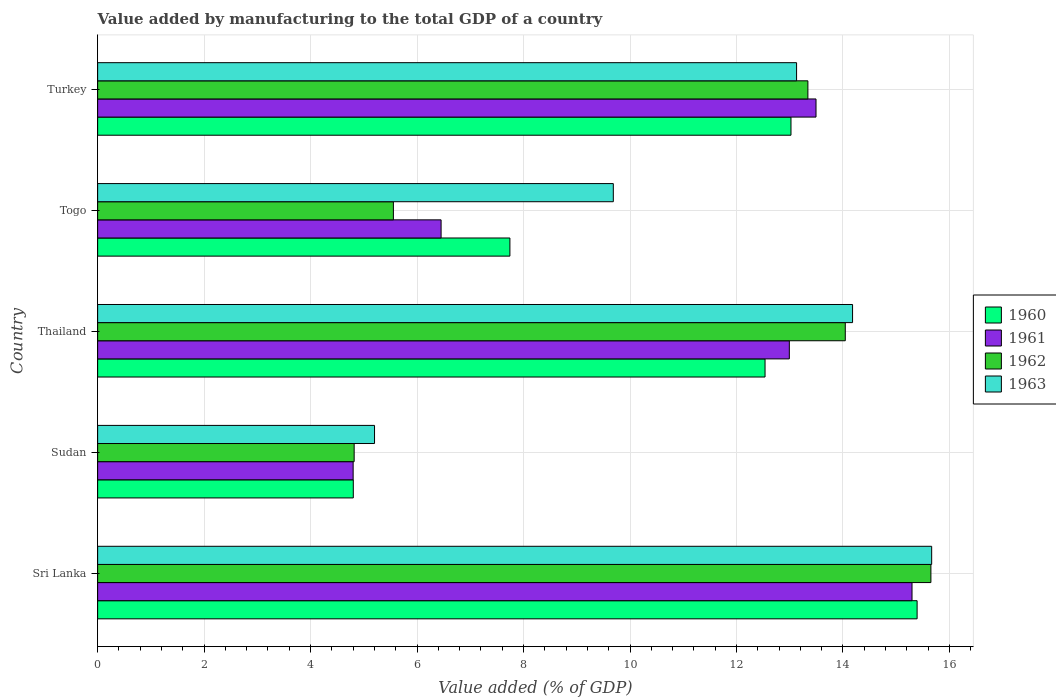How many groups of bars are there?
Ensure brevity in your answer.  5. Are the number of bars per tick equal to the number of legend labels?
Your answer should be compact. Yes. Are the number of bars on each tick of the Y-axis equal?
Your response must be concise. Yes. How many bars are there on the 3rd tick from the top?
Provide a succinct answer. 4. How many bars are there on the 3rd tick from the bottom?
Offer a terse response. 4. What is the label of the 2nd group of bars from the top?
Your answer should be compact. Togo. In how many cases, is the number of bars for a given country not equal to the number of legend labels?
Offer a terse response. 0. What is the value added by manufacturing to the total GDP in 1962 in Turkey?
Give a very brief answer. 13.34. Across all countries, what is the maximum value added by manufacturing to the total GDP in 1963?
Your answer should be very brief. 15.67. Across all countries, what is the minimum value added by manufacturing to the total GDP in 1962?
Your answer should be compact. 4.82. In which country was the value added by manufacturing to the total GDP in 1960 maximum?
Provide a short and direct response. Sri Lanka. In which country was the value added by manufacturing to the total GDP in 1960 minimum?
Keep it short and to the point. Sudan. What is the total value added by manufacturing to the total GDP in 1963 in the graph?
Your answer should be compact. 57.86. What is the difference between the value added by manufacturing to the total GDP in 1963 in Thailand and that in Togo?
Make the answer very short. 4.49. What is the difference between the value added by manufacturing to the total GDP in 1961 in Togo and the value added by manufacturing to the total GDP in 1963 in Thailand?
Your answer should be compact. -7.73. What is the average value added by manufacturing to the total GDP in 1961 per country?
Your answer should be compact. 10.61. What is the difference between the value added by manufacturing to the total GDP in 1963 and value added by manufacturing to the total GDP in 1961 in Togo?
Offer a terse response. 3.23. What is the ratio of the value added by manufacturing to the total GDP in 1961 in Sudan to that in Togo?
Make the answer very short. 0.74. Is the value added by manufacturing to the total GDP in 1960 in Thailand less than that in Turkey?
Your answer should be compact. Yes. Is the difference between the value added by manufacturing to the total GDP in 1963 in Sudan and Thailand greater than the difference between the value added by manufacturing to the total GDP in 1961 in Sudan and Thailand?
Your answer should be compact. No. What is the difference between the highest and the second highest value added by manufacturing to the total GDP in 1962?
Offer a very short reply. 1.61. What is the difference between the highest and the lowest value added by manufacturing to the total GDP in 1960?
Ensure brevity in your answer.  10.59. Is the sum of the value added by manufacturing to the total GDP in 1963 in Thailand and Togo greater than the maximum value added by manufacturing to the total GDP in 1960 across all countries?
Provide a short and direct response. Yes. Is it the case that in every country, the sum of the value added by manufacturing to the total GDP in 1962 and value added by manufacturing to the total GDP in 1963 is greater than the sum of value added by manufacturing to the total GDP in 1961 and value added by manufacturing to the total GDP in 1960?
Your answer should be compact. No. What does the 1st bar from the bottom in Togo represents?
Make the answer very short. 1960. How many bars are there?
Keep it short and to the point. 20. Are all the bars in the graph horizontal?
Your response must be concise. Yes. How many countries are there in the graph?
Offer a terse response. 5. What is the difference between two consecutive major ticks on the X-axis?
Keep it short and to the point. 2. Are the values on the major ticks of X-axis written in scientific E-notation?
Provide a succinct answer. No. Does the graph contain grids?
Ensure brevity in your answer.  Yes. Where does the legend appear in the graph?
Your answer should be very brief. Center right. How many legend labels are there?
Keep it short and to the point. 4. What is the title of the graph?
Provide a succinct answer. Value added by manufacturing to the total GDP of a country. What is the label or title of the X-axis?
Offer a very short reply. Value added (% of GDP). What is the Value added (% of GDP) of 1960 in Sri Lanka?
Keep it short and to the point. 15.39. What is the Value added (% of GDP) of 1961 in Sri Lanka?
Your answer should be compact. 15.3. What is the Value added (% of GDP) of 1962 in Sri Lanka?
Your answer should be compact. 15.65. What is the Value added (% of GDP) in 1963 in Sri Lanka?
Provide a short and direct response. 15.67. What is the Value added (% of GDP) in 1960 in Sudan?
Give a very brief answer. 4.8. What is the Value added (% of GDP) in 1961 in Sudan?
Offer a very short reply. 4.8. What is the Value added (% of GDP) of 1962 in Sudan?
Offer a terse response. 4.82. What is the Value added (% of GDP) in 1963 in Sudan?
Your response must be concise. 5.2. What is the Value added (% of GDP) in 1960 in Thailand?
Keep it short and to the point. 12.54. What is the Value added (% of GDP) in 1961 in Thailand?
Your answer should be very brief. 12.99. What is the Value added (% of GDP) in 1962 in Thailand?
Ensure brevity in your answer.  14.04. What is the Value added (% of GDP) in 1963 in Thailand?
Provide a succinct answer. 14.18. What is the Value added (% of GDP) of 1960 in Togo?
Your response must be concise. 7.74. What is the Value added (% of GDP) of 1961 in Togo?
Ensure brevity in your answer.  6.45. What is the Value added (% of GDP) of 1962 in Togo?
Give a very brief answer. 5.56. What is the Value added (% of GDP) in 1963 in Togo?
Provide a short and direct response. 9.69. What is the Value added (% of GDP) in 1960 in Turkey?
Keep it short and to the point. 13.02. What is the Value added (% of GDP) in 1961 in Turkey?
Make the answer very short. 13.49. What is the Value added (% of GDP) in 1962 in Turkey?
Ensure brevity in your answer.  13.34. What is the Value added (% of GDP) in 1963 in Turkey?
Provide a short and direct response. 13.13. Across all countries, what is the maximum Value added (% of GDP) in 1960?
Your answer should be compact. 15.39. Across all countries, what is the maximum Value added (% of GDP) in 1961?
Give a very brief answer. 15.3. Across all countries, what is the maximum Value added (% of GDP) of 1962?
Your answer should be very brief. 15.65. Across all countries, what is the maximum Value added (% of GDP) of 1963?
Offer a very short reply. 15.67. Across all countries, what is the minimum Value added (% of GDP) in 1960?
Your answer should be very brief. 4.8. Across all countries, what is the minimum Value added (% of GDP) in 1961?
Make the answer very short. 4.8. Across all countries, what is the minimum Value added (% of GDP) of 1962?
Make the answer very short. 4.82. Across all countries, what is the minimum Value added (% of GDP) in 1963?
Ensure brevity in your answer.  5.2. What is the total Value added (% of GDP) in 1960 in the graph?
Make the answer very short. 53.5. What is the total Value added (% of GDP) of 1961 in the graph?
Ensure brevity in your answer.  53.04. What is the total Value added (% of GDP) of 1962 in the graph?
Provide a short and direct response. 53.41. What is the total Value added (% of GDP) in 1963 in the graph?
Provide a succinct answer. 57.86. What is the difference between the Value added (% of GDP) in 1960 in Sri Lanka and that in Sudan?
Offer a very short reply. 10.59. What is the difference between the Value added (% of GDP) of 1961 in Sri Lanka and that in Sudan?
Provide a succinct answer. 10.5. What is the difference between the Value added (% of GDP) of 1962 in Sri Lanka and that in Sudan?
Ensure brevity in your answer.  10.83. What is the difference between the Value added (% of GDP) of 1963 in Sri Lanka and that in Sudan?
Ensure brevity in your answer.  10.47. What is the difference between the Value added (% of GDP) in 1960 in Sri Lanka and that in Thailand?
Make the answer very short. 2.86. What is the difference between the Value added (% of GDP) of 1961 in Sri Lanka and that in Thailand?
Provide a succinct answer. 2.3. What is the difference between the Value added (% of GDP) in 1962 in Sri Lanka and that in Thailand?
Provide a short and direct response. 1.61. What is the difference between the Value added (% of GDP) of 1963 in Sri Lanka and that in Thailand?
Provide a succinct answer. 1.49. What is the difference between the Value added (% of GDP) of 1960 in Sri Lanka and that in Togo?
Provide a succinct answer. 7.65. What is the difference between the Value added (% of GDP) in 1961 in Sri Lanka and that in Togo?
Keep it short and to the point. 8.85. What is the difference between the Value added (% of GDP) of 1962 in Sri Lanka and that in Togo?
Offer a very short reply. 10.1. What is the difference between the Value added (% of GDP) in 1963 in Sri Lanka and that in Togo?
Offer a terse response. 5.98. What is the difference between the Value added (% of GDP) in 1960 in Sri Lanka and that in Turkey?
Your answer should be compact. 2.37. What is the difference between the Value added (% of GDP) in 1961 in Sri Lanka and that in Turkey?
Offer a very short reply. 1.8. What is the difference between the Value added (% of GDP) in 1962 in Sri Lanka and that in Turkey?
Keep it short and to the point. 2.31. What is the difference between the Value added (% of GDP) in 1963 in Sri Lanka and that in Turkey?
Provide a short and direct response. 2.54. What is the difference between the Value added (% of GDP) of 1960 in Sudan and that in Thailand?
Offer a very short reply. -7.73. What is the difference between the Value added (% of GDP) in 1961 in Sudan and that in Thailand?
Make the answer very short. -8.19. What is the difference between the Value added (% of GDP) of 1962 in Sudan and that in Thailand?
Your answer should be compact. -9.23. What is the difference between the Value added (% of GDP) of 1963 in Sudan and that in Thailand?
Your response must be concise. -8.98. What is the difference between the Value added (% of GDP) of 1960 in Sudan and that in Togo?
Keep it short and to the point. -2.94. What is the difference between the Value added (% of GDP) of 1961 in Sudan and that in Togo?
Your answer should be compact. -1.65. What is the difference between the Value added (% of GDP) in 1962 in Sudan and that in Togo?
Offer a terse response. -0.74. What is the difference between the Value added (% of GDP) in 1963 in Sudan and that in Togo?
Offer a terse response. -4.49. What is the difference between the Value added (% of GDP) in 1960 in Sudan and that in Turkey?
Provide a short and direct response. -8.22. What is the difference between the Value added (% of GDP) of 1961 in Sudan and that in Turkey?
Offer a very short reply. -8.69. What is the difference between the Value added (% of GDP) of 1962 in Sudan and that in Turkey?
Ensure brevity in your answer.  -8.52. What is the difference between the Value added (% of GDP) of 1963 in Sudan and that in Turkey?
Offer a very short reply. -7.93. What is the difference between the Value added (% of GDP) of 1960 in Thailand and that in Togo?
Provide a short and direct response. 4.79. What is the difference between the Value added (% of GDP) in 1961 in Thailand and that in Togo?
Provide a short and direct response. 6.54. What is the difference between the Value added (% of GDP) of 1962 in Thailand and that in Togo?
Your response must be concise. 8.49. What is the difference between the Value added (% of GDP) of 1963 in Thailand and that in Togo?
Offer a terse response. 4.49. What is the difference between the Value added (% of GDP) of 1960 in Thailand and that in Turkey?
Provide a short and direct response. -0.49. What is the difference between the Value added (% of GDP) of 1961 in Thailand and that in Turkey?
Make the answer very short. -0.5. What is the difference between the Value added (% of GDP) of 1962 in Thailand and that in Turkey?
Ensure brevity in your answer.  0.7. What is the difference between the Value added (% of GDP) in 1963 in Thailand and that in Turkey?
Keep it short and to the point. 1.05. What is the difference between the Value added (% of GDP) of 1960 in Togo and that in Turkey?
Your response must be concise. -5.28. What is the difference between the Value added (% of GDP) in 1961 in Togo and that in Turkey?
Your answer should be very brief. -7.04. What is the difference between the Value added (% of GDP) in 1962 in Togo and that in Turkey?
Make the answer very short. -7.79. What is the difference between the Value added (% of GDP) in 1963 in Togo and that in Turkey?
Your answer should be compact. -3.44. What is the difference between the Value added (% of GDP) in 1960 in Sri Lanka and the Value added (% of GDP) in 1961 in Sudan?
Provide a succinct answer. 10.59. What is the difference between the Value added (% of GDP) in 1960 in Sri Lanka and the Value added (% of GDP) in 1962 in Sudan?
Offer a terse response. 10.57. What is the difference between the Value added (% of GDP) in 1960 in Sri Lanka and the Value added (% of GDP) in 1963 in Sudan?
Provide a succinct answer. 10.19. What is the difference between the Value added (% of GDP) of 1961 in Sri Lanka and the Value added (% of GDP) of 1962 in Sudan?
Keep it short and to the point. 10.48. What is the difference between the Value added (% of GDP) of 1961 in Sri Lanka and the Value added (% of GDP) of 1963 in Sudan?
Your response must be concise. 10.1. What is the difference between the Value added (% of GDP) of 1962 in Sri Lanka and the Value added (% of GDP) of 1963 in Sudan?
Keep it short and to the point. 10.45. What is the difference between the Value added (% of GDP) of 1960 in Sri Lanka and the Value added (% of GDP) of 1961 in Thailand?
Offer a very short reply. 2.4. What is the difference between the Value added (% of GDP) in 1960 in Sri Lanka and the Value added (% of GDP) in 1962 in Thailand?
Provide a short and direct response. 1.35. What is the difference between the Value added (% of GDP) in 1960 in Sri Lanka and the Value added (% of GDP) in 1963 in Thailand?
Your answer should be compact. 1.21. What is the difference between the Value added (% of GDP) in 1961 in Sri Lanka and the Value added (% of GDP) in 1962 in Thailand?
Offer a terse response. 1.25. What is the difference between the Value added (% of GDP) in 1961 in Sri Lanka and the Value added (% of GDP) in 1963 in Thailand?
Give a very brief answer. 1.12. What is the difference between the Value added (% of GDP) in 1962 in Sri Lanka and the Value added (% of GDP) in 1963 in Thailand?
Your answer should be compact. 1.47. What is the difference between the Value added (% of GDP) in 1960 in Sri Lanka and the Value added (% of GDP) in 1961 in Togo?
Make the answer very short. 8.94. What is the difference between the Value added (% of GDP) in 1960 in Sri Lanka and the Value added (% of GDP) in 1962 in Togo?
Provide a short and direct response. 9.84. What is the difference between the Value added (% of GDP) of 1960 in Sri Lanka and the Value added (% of GDP) of 1963 in Togo?
Offer a terse response. 5.71. What is the difference between the Value added (% of GDP) of 1961 in Sri Lanka and the Value added (% of GDP) of 1962 in Togo?
Offer a very short reply. 9.74. What is the difference between the Value added (% of GDP) of 1961 in Sri Lanka and the Value added (% of GDP) of 1963 in Togo?
Ensure brevity in your answer.  5.61. What is the difference between the Value added (% of GDP) of 1962 in Sri Lanka and the Value added (% of GDP) of 1963 in Togo?
Make the answer very short. 5.97. What is the difference between the Value added (% of GDP) in 1960 in Sri Lanka and the Value added (% of GDP) in 1961 in Turkey?
Your response must be concise. 1.9. What is the difference between the Value added (% of GDP) in 1960 in Sri Lanka and the Value added (% of GDP) in 1962 in Turkey?
Provide a short and direct response. 2.05. What is the difference between the Value added (% of GDP) of 1960 in Sri Lanka and the Value added (% of GDP) of 1963 in Turkey?
Provide a short and direct response. 2.26. What is the difference between the Value added (% of GDP) in 1961 in Sri Lanka and the Value added (% of GDP) in 1962 in Turkey?
Keep it short and to the point. 1.96. What is the difference between the Value added (% of GDP) in 1961 in Sri Lanka and the Value added (% of GDP) in 1963 in Turkey?
Give a very brief answer. 2.17. What is the difference between the Value added (% of GDP) in 1962 in Sri Lanka and the Value added (% of GDP) in 1963 in Turkey?
Your answer should be very brief. 2.52. What is the difference between the Value added (% of GDP) in 1960 in Sudan and the Value added (% of GDP) in 1961 in Thailand?
Keep it short and to the point. -8.19. What is the difference between the Value added (% of GDP) of 1960 in Sudan and the Value added (% of GDP) of 1962 in Thailand?
Offer a terse response. -9.24. What is the difference between the Value added (% of GDP) of 1960 in Sudan and the Value added (% of GDP) of 1963 in Thailand?
Offer a terse response. -9.38. What is the difference between the Value added (% of GDP) in 1961 in Sudan and the Value added (% of GDP) in 1962 in Thailand?
Your answer should be very brief. -9.24. What is the difference between the Value added (% of GDP) in 1961 in Sudan and the Value added (% of GDP) in 1963 in Thailand?
Your response must be concise. -9.38. What is the difference between the Value added (% of GDP) in 1962 in Sudan and the Value added (% of GDP) in 1963 in Thailand?
Keep it short and to the point. -9.36. What is the difference between the Value added (% of GDP) in 1960 in Sudan and the Value added (% of GDP) in 1961 in Togo?
Offer a terse response. -1.65. What is the difference between the Value added (% of GDP) in 1960 in Sudan and the Value added (% of GDP) in 1962 in Togo?
Ensure brevity in your answer.  -0.75. What is the difference between the Value added (% of GDP) in 1960 in Sudan and the Value added (% of GDP) in 1963 in Togo?
Give a very brief answer. -4.88. What is the difference between the Value added (% of GDP) in 1961 in Sudan and the Value added (% of GDP) in 1962 in Togo?
Provide a short and direct response. -0.76. What is the difference between the Value added (% of GDP) in 1961 in Sudan and the Value added (% of GDP) in 1963 in Togo?
Make the answer very short. -4.89. What is the difference between the Value added (% of GDP) in 1962 in Sudan and the Value added (% of GDP) in 1963 in Togo?
Offer a terse response. -4.87. What is the difference between the Value added (% of GDP) of 1960 in Sudan and the Value added (% of GDP) of 1961 in Turkey?
Offer a very short reply. -8.69. What is the difference between the Value added (% of GDP) in 1960 in Sudan and the Value added (% of GDP) in 1962 in Turkey?
Offer a very short reply. -8.54. What is the difference between the Value added (% of GDP) of 1960 in Sudan and the Value added (% of GDP) of 1963 in Turkey?
Offer a terse response. -8.33. What is the difference between the Value added (% of GDP) of 1961 in Sudan and the Value added (% of GDP) of 1962 in Turkey?
Provide a short and direct response. -8.54. What is the difference between the Value added (% of GDP) in 1961 in Sudan and the Value added (% of GDP) in 1963 in Turkey?
Offer a terse response. -8.33. What is the difference between the Value added (% of GDP) of 1962 in Sudan and the Value added (% of GDP) of 1963 in Turkey?
Provide a succinct answer. -8.31. What is the difference between the Value added (% of GDP) of 1960 in Thailand and the Value added (% of GDP) of 1961 in Togo?
Provide a short and direct response. 6.09. What is the difference between the Value added (% of GDP) of 1960 in Thailand and the Value added (% of GDP) of 1962 in Togo?
Keep it short and to the point. 6.98. What is the difference between the Value added (% of GDP) of 1960 in Thailand and the Value added (% of GDP) of 1963 in Togo?
Your response must be concise. 2.85. What is the difference between the Value added (% of GDP) in 1961 in Thailand and the Value added (% of GDP) in 1962 in Togo?
Offer a very short reply. 7.44. What is the difference between the Value added (% of GDP) in 1961 in Thailand and the Value added (% of GDP) in 1963 in Togo?
Offer a terse response. 3.31. What is the difference between the Value added (% of GDP) of 1962 in Thailand and the Value added (% of GDP) of 1963 in Togo?
Provide a succinct answer. 4.36. What is the difference between the Value added (% of GDP) in 1960 in Thailand and the Value added (% of GDP) in 1961 in Turkey?
Make the answer very short. -0.96. What is the difference between the Value added (% of GDP) of 1960 in Thailand and the Value added (% of GDP) of 1962 in Turkey?
Your response must be concise. -0.81. What is the difference between the Value added (% of GDP) in 1960 in Thailand and the Value added (% of GDP) in 1963 in Turkey?
Offer a very short reply. -0.59. What is the difference between the Value added (% of GDP) in 1961 in Thailand and the Value added (% of GDP) in 1962 in Turkey?
Make the answer very short. -0.35. What is the difference between the Value added (% of GDP) in 1961 in Thailand and the Value added (% of GDP) in 1963 in Turkey?
Your response must be concise. -0.14. What is the difference between the Value added (% of GDP) in 1962 in Thailand and the Value added (% of GDP) in 1963 in Turkey?
Ensure brevity in your answer.  0.92. What is the difference between the Value added (% of GDP) in 1960 in Togo and the Value added (% of GDP) in 1961 in Turkey?
Your response must be concise. -5.75. What is the difference between the Value added (% of GDP) in 1960 in Togo and the Value added (% of GDP) in 1962 in Turkey?
Offer a terse response. -5.6. What is the difference between the Value added (% of GDP) of 1960 in Togo and the Value added (% of GDP) of 1963 in Turkey?
Ensure brevity in your answer.  -5.38. What is the difference between the Value added (% of GDP) in 1961 in Togo and the Value added (% of GDP) in 1962 in Turkey?
Provide a succinct answer. -6.89. What is the difference between the Value added (% of GDP) in 1961 in Togo and the Value added (% of GDP) in 1963 in Turkey?
Provide a short and direct response. -6.68. What is the difference between the Value added (% of GDP) in 1962 in Togo and the Value added (% of GDP) in 1963 in Turkey?
Your answer should be compact. -7.57. What is the average Value added (% of GDP) of 1960 per country?
Your answer should be very brief. 10.7. What is the average Value added (% of GDP) in 1961 per country?
Your response must be concise. 10.61. What is the average Value added (% of GDP) in 1962 per country?
Give a very brief answer. 10.68. What is the average Value added (% of GDP) in 1963 per country?
Offer a terse response. 11.57. What is the difference between the Value added (% of GDP) in 1960 and Value added (% of GDP) in 1961 in Sri Lanka?
Give a very brief answer. 0.1. What is the difference between the Value added (% of GDP) in 1960 and Value added (% of GDP) in 1962 in Sri Lanka?
Your answer should be very brief. -0.26. What is the difference between the Value added (% of GDP) in 1960 and Value added (% of GDP) in 1963 in Sri Lanka?
Your response must be concise. -0.27. What is the difference between the Value added (% of GDP) in 1961 and Value added (% of GDP) in 1962 in Sri Lanka?
Your response must be concise. -0.35. What is the difference between the Value added (% of GDP) of 1961 and Value added (% of GDP) of 1963 in Sri Lanka?
Ensure brevity in your answer.  -0.37. What is the difference between the Value added (% of GDP) of 1962 and Value added (% of GDP) of 1963 in Sri Lanka?
Provide a short and direct response. -0.01. What is the difference between the Value added (% of GDP) in 1960 and Value added (% of GDP) in 1961 in Sudan?
Your answer should be compact. 0. What is the difference between the Value added (% of GDP) of 1960 and Value added (% of GDP) of 1962 in Sudan?
Keep it short and to the point. -0.02. What is the difference between the Value added (% of GDP) of 1960 and Value added (% of GDP) of 1963 in Sudan?
Your answer should be very brief. -0.4. What is the difference between the Value added (% of GDP) in 1961 and Value added (% of GDP) in 1962 in Sudan?
Offer a very short reply. -0.02. What is the difference between the Value added (% of GDP) of 1961 and Value added (% of GDP) of 1963 in Sudan?
Provide a short and direct response. -0.4. What is the difference between the Value added (% of GDP) of 1962 and Value added (% of GDP) of 1963 in Sudan?
Offer a very short reply. -0.38. What is the difference between the Value added (% of GDP) in 1960 and Value added (% of GDP) in 1961 in Thailand?
Your answer should be very brief. -0.46. What is the difference between the Value added (% of GDP) in 1960 and Value added (% of GDP) in 1962 in Thailand?
Ensure brevity in your answer.  -1.51. What is the difference between the Value added (% of GDP) of 1960 and Value added (% of GDP) of 1963 in Thailand?
Make the answer very short. -1.64. What is the difference between the Value added (% of GDP) of 1961 and Value added (% of GDP) of 1962 in Thailand?
Provide a short and direct response. -1.05. What is the difference between the Value added (% of GDP) in 1961 and Value added (% of GDP) in 1963 in Thailand?
Give a very brief answer. -1.19. What is the difference between the Value added (% of GDP) of 1962 and Value added (% of GDP) of 1963 in Thailand?
Offer a very short reply. -0.14. What is the difference between the Value added (% of GDP) of 1960 and Value added (% of GDP) of 1961 in Togo?
Keep it short and to the point. 1.29. What is the difference between the Value added (% of GDP) of 1960 and Value added (% of GDP) of 1962 in Togo?
Offer a terse response. 2.19. What is the difference between the Value added (% of GDP) in 1960 and Value added (% of GDP) in 1963 in Togo?
Ensure brevity in your answer.  -1.94. What is the difference between the Value added (% of GDP) of 1961 and Value added (% of GDP) of 1962 in Togo?
Keep it short and to the point. 0.9. What is the difference between the Value added (% of GDP) of 1961 and Value added (% of GDP) of 1963 in Togo?
Your answer should be very brief. -3.23. What is the difference between the Value added (% of GDP) in 1962 and Value added (% of GDP) in 1963 in Togo?
Give a very brief answer. -4.13. What is the difference between the Value added (% of GDP) in 1960 and Value added (% of GDP) in 1961 in Turkey?
Offer a terse response. -0.47. What is the difference between the Value added (% of GDP) in 1960 and Value added (% of GDP) in 1962 in Turkey?
Provide a succinct answer. -0.32. What is the difference between the Value added (% of GDP) in 1960 and Value added (% of GDP) in 1963 in Turkey?
Give a very brief answer. -0.11. What is the difference between the Value added (% of GDP) in 1961 and Value added (% of GDP) in 1962 in Turkey?
Keep it short and to the point. 0.15. What is the difference between the Value added (% of GDP) of 1961 and Value added (% of GDP) of 1963 in Turkey?
Your answer should be compact. 0.37. What is the difference between the Value added (% of GDP) of 1962 and Value added (% of GDP) of 1963 in Turkey?
Offer a very short reply. 0.21. What is the ratio of the Value added (% of GDP) in 1960 in Sri Lanka to that in Sudan?
Offer a terse response. 3.21. What is the ratio of the Value added (% of GDP) of 1961 in Sri Lanka to that in Sudan?
Make the answer very short. 3.19. What is the ratio of the Value added (% of GDP) of 1962 in Sri Lanka to that in Sudan?
Offer a very short reply. 3.25. What is the ratio of the Value added (% of GDP) in 1963 in Sri Lanka to that in Sudan?
Your answer should be very brief. 3.01. What is the ratio of the Value added (% of GDP) of 1960 in Sri Lanka to that in Thailand?
Your answer should be compact. 1.23. What is the ratio of the Value added (% of GDP) of 1961 in Sri Lanka to that in Thailand?
Give a very brief answer. 1.18. What is the ratio of the Value added (% of GDP) in 1962 in Sri Lanka to that in Thailand?
Offer a very short reply. 1.11. What is the ratio of the Value added (% of GDP) in 1963 in Sri Lanka to that in Thailand?
Keep it short and to the point. 1.1. What is the ratio of the Value added (% of GDP) of 1960 in Sri Lanka to that in Togo?
Your answer should be very brief. 1.99. What is the ratio of the Value added (% of GDP) of 1961 in Sri Lanka to that in Togo?
Provide a succinct answer. 2.37. What is the ratio of the Value added (% of GDP) of 1962 in Sri Lanka to that in Togo?
Keep it short and to the point. 2.82. What is the ratio of the Value added (% of GDP) in 1963 in Sri Lanka to that in Togo?
Offer a terse response. 1.62. What is the ratio of the Value added (% of GDP) in 1960 in Sri Lanka to that in Turkey?
Keep it short and to the point. 1.18. What is the ratio of the Value added (% of GDP) of 1961 in Sri Lanka to that in Turkey?
Ensure brevity in your answer.  1.13. What is the ratio of the Value added (% of GDP) in 1962 in Sri Lanka to that in Turkey?
Your response must be concise. 1.17. What is the ratio of the Value added (% of GDP) in 1963 in Sri Lanka to that in Turkey?
Your answer should be very brief. 1.19. What is the ratio of the Value added (% of GDP) of 1960 in Sudan to that in Thailand?
Your answer should be very brief. 0.38. What is the ratio of the Value added (% of GDP) of 1961 in Sudan to that in Thailand?
Offer a very short reply. 0.37. What is the ratio of the Value added (% of GDP) of 1962 in Sudan to that in Thailand?
Provide a short and direct response. 0.34. What is the ratio of the Value added (% of GDP) in 1963 in Sudan to that in Thailand?
Your response must be concise. 0.37. What is the ratio of the Value added (% of GDP) of 1960 in Sudan to that in Togo?
Your response must be concise. 0.62. What is the ratio of the Value added (% of GDP) of 1961 in Sudan to that in Togo?
Ensure brevity in your answer.  0.74. What is the ratio of the Value added (% of GDP) in 1962 in Sudan to that in Togo?
Ensure brevity in your answer.  0.87. What is the ratio of the Value added (% of GDP) of 1963 in Sudan to that in Togo?
Provide a short and direct response. 0.54. What is the ratio of the Value added (% of GDP) in 1960 in Sudan to that in Turkey?
Provide a succinct answer. 0.37. What is the ratio of the Value added (% of GDP) in 1961 in Sudan to that in Turkey?
Make the answer very short. 0.36. What is the ratio of the Value added (% of GDP) in 1962 in Sudan to that in Turkey?
Your answer should be compact. 0.36. What is the ratio of the Value added (% of GDP) of 1963 in Sudan to that in Turkey?
Provide a succinct answer. 0.4. What is the ratio of the Value added (% of GDP) of 1960 in Thailand to that in Togo?
Keep it short and to the point. 1.62. What is the ratio of the Value added (% of GDP) in 1961 in Thailand to that in Togo?
Offer a very short reply. 2.01. What is the ratio of the Value added (% of GDP) in 1962 in Thailand to that in Togo?
Offer a terse response. 2.53. What is the ratio of the Value added (% of GDP) of 1963 in Thailand to that in Togo?
Offer a very short reply. 1.46. What is the ratio of the Value added (% of GDP) of 1960 in Thailand to that in Turkey?
Keep it short and to the point. 0.96. What is the ratio of the Value added (% of GDP) of 1961 in Thailand to that in Turkey?
Your response must be concise. 0.96. What is the ratio of the Value added (% of GDP) in 1962 in Thailand to that in Turkey?
Ensure brevity in your answer.  1.05. What is the ratio of the Value added (% of GDP) of 1963 in Thailand to that in Turkey?
Your response must be concise. 1.08. What is the ratio of the Value added (% of GDP) of 1960 in Togo to that in Turkey?
Your answer should be compact. 0.59. What is the ratio of the Value added (% of GDP) in 1961 in Togo to that in Turkey?
Make the answer very short. 0.48. What is the ratio of the Value added (% of GDP) in 1962 in Togo to that in Turkey?
Offer a very short reply. 0.42. What is the ratio of the Value added (% of GDP) of 1963 in Togo to that in Turkey?
Provide a succinct answer. 0.74. What is the difference between the highest and the second highest Value added (% of GDP) of 1960?
Offer a terse response. 2.37. What is the difference between the highest and the second highest Value added (% of GDP) in 1961?
Provide a short and direct response. 1.8. What is the difference between the highest and the second highest Value added (% of GDP) in 1962?
Keep it short and to the point. 1.61. What is the difference between the highest and the second highest Value added (% of GDP) of 1963?
Offer a very short reply. 1.49. What is the difference between the highest and the lowest Value added (% of GDP) of 1960?
Provide a short and direct response. 10.59. What is the difference between the highest and the lowest Value added (% of GDP) in 1961?
Your answer should be very brief. 10.5. What is the difference between the highest and the lowest Value added (% of GDP) in 1962?
Offer a very short reply. 10.83. What is the difference between the highest and the lowest Value added (% of GDP) of 1963?
Your response must be concise. 10.47. 